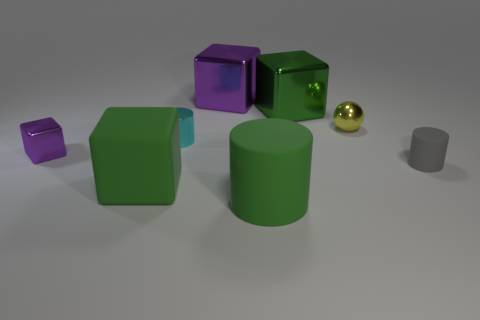Are there fewer large matte things behind the yellow ball than cyan cylinders on the right side of the tiny metal cube?
Your answer should be very brief. Yes. There is a large green thing that is made of the same material as the green cylinder; what shape is it?
Offer a terse response. Cube. What size is the cylinder to the left of the rubber cylinder that is to the left of the tiny metallic object that is behind the shiny cylinder?
Provide a short and direct response. Small. Is the number of cyan cylinders greater than the number of tiny cyan spheres?
Offer a very short reply. Yes. Do the large rubber thing that is left of the small cyan shiny cylinder and the small metal thing right of the tiny cyan metallic thing have the same color?
Provide a succinct answer. No. Are the block in front of the tiny gray cylinder and the cube to the left of the big matte block made of the same material?
Provide a short and direct response. No. What number of other gray matte objects are the same size as the gray matte thing?
Make the answer very short. 0. Are there fewer metal spheres than big metallic things?
Your response must be concise. Yes. There is a tiny metal thing that is right of the purple metallic thing that is behind the small yellow metal ball; what is its shape?
Give a very brief answer. Sphere. What is the shape of the yellow shiny object that is the same size as the gray matte object?
Your answer should be compact. Sphere. 